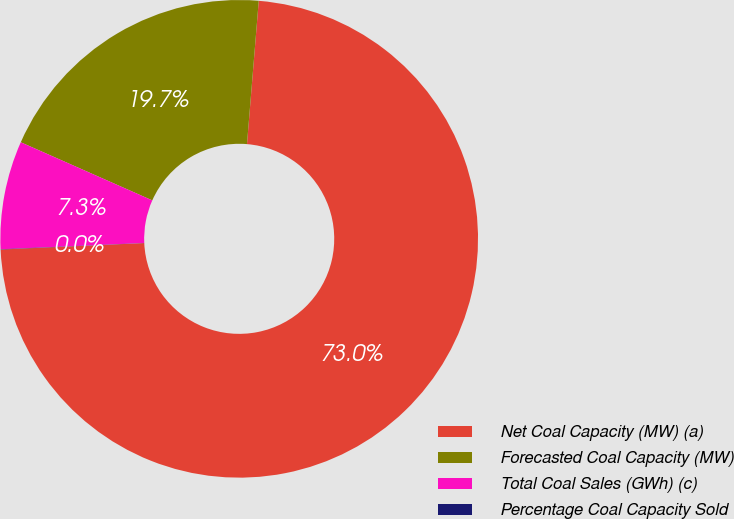<chart> <loc_0><loc_0><loc_500><loc_500><pie_chart><fcel>Net Coal Capacity (MW) (a)<fcel>Forecasted Coal Capacity (MW)<fcel>Total Coal Sales (GWh) (c)<fcel>Percentage Coal Capacity Sold<nl><fcel>72.98%<fcel>19.68%<fcel>7.32%<fcel>0.02%<nl></chart> 